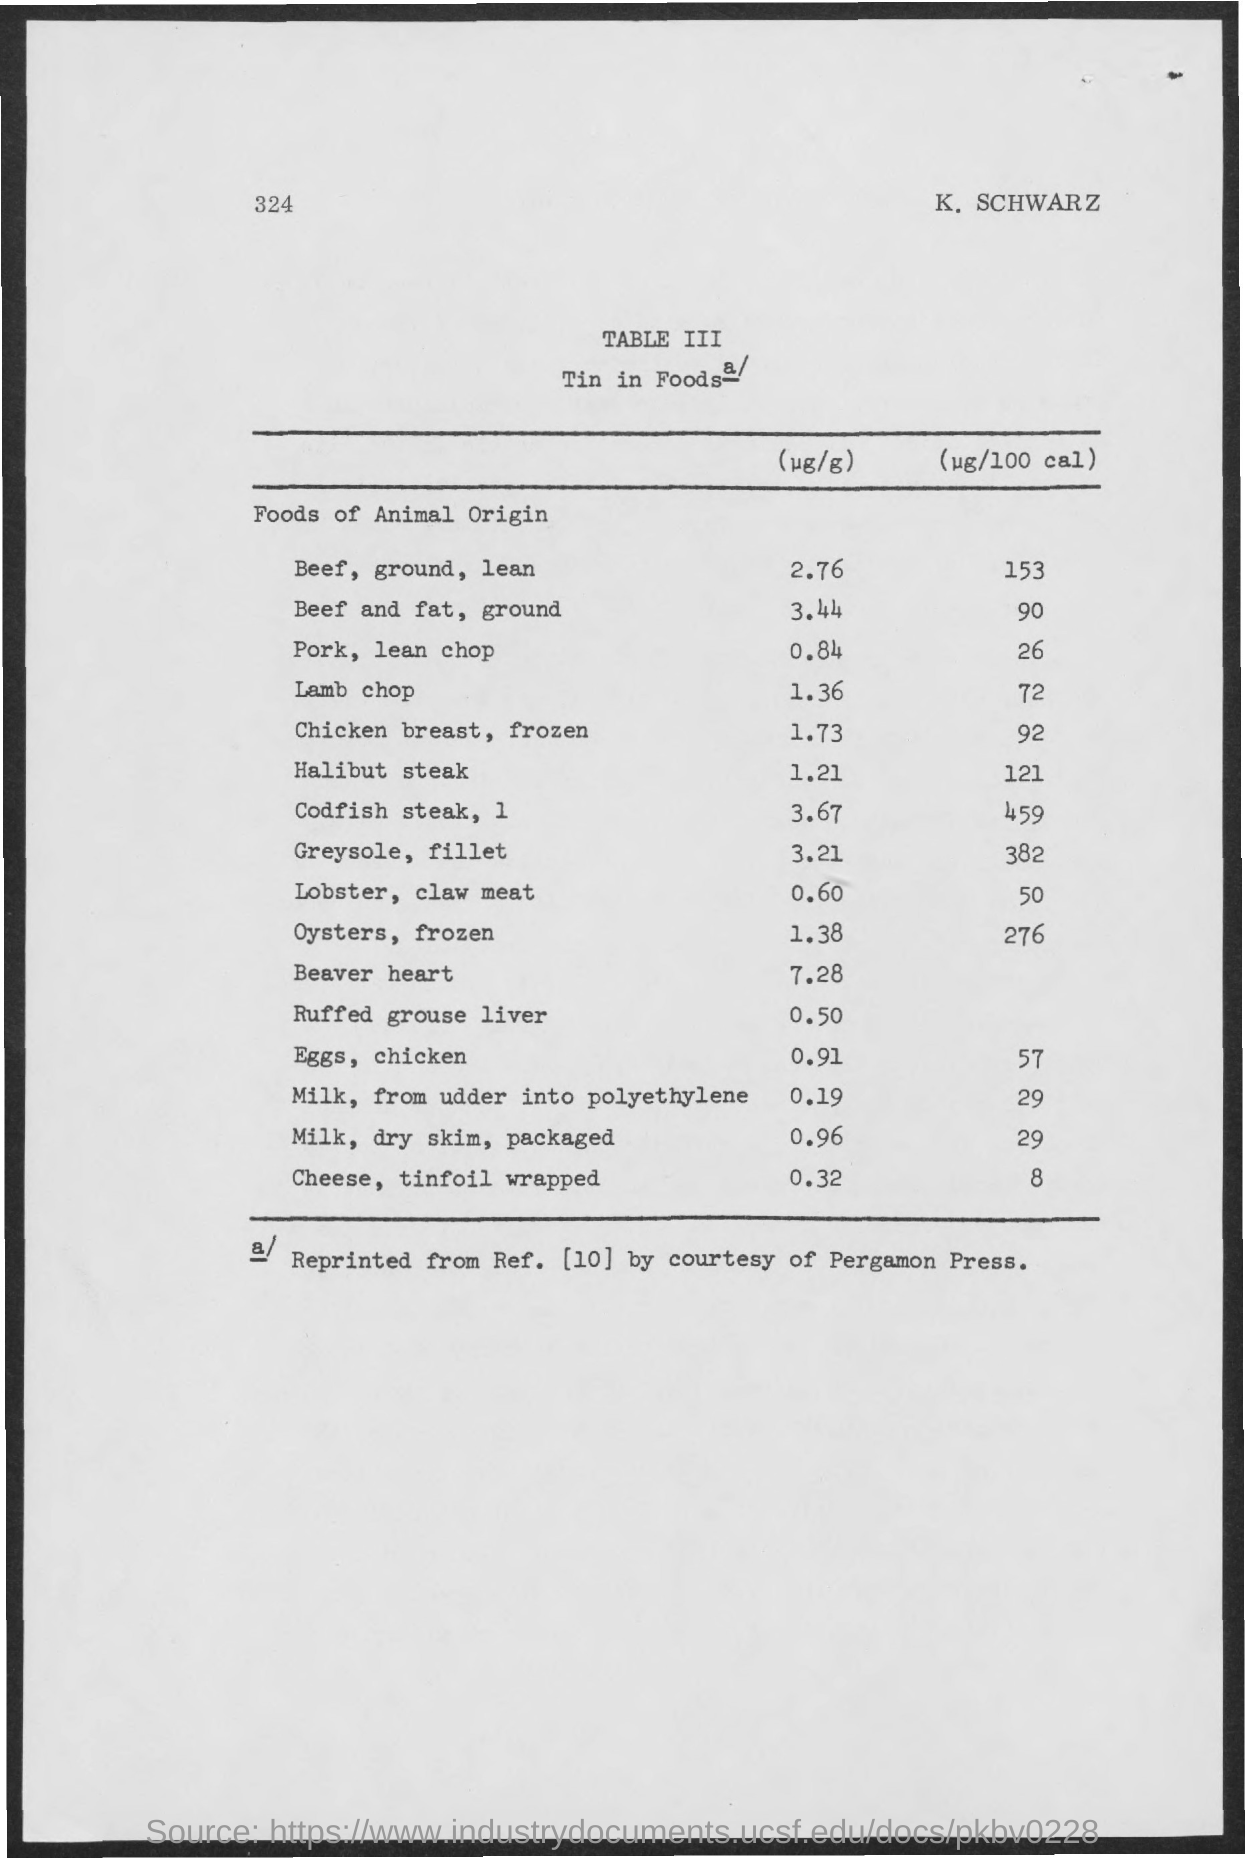List a handful of essential elements in this visual. The name mentioned at the top right of the page is "K. Schwarz. The ground beef contained 2.76 micrograms of lead per gram, as reported. The table number mentioned in the given page is Table III. The title of the table is "Tin in Foods. On the top left side of the page, there is a number mentioned. The number is 324. 